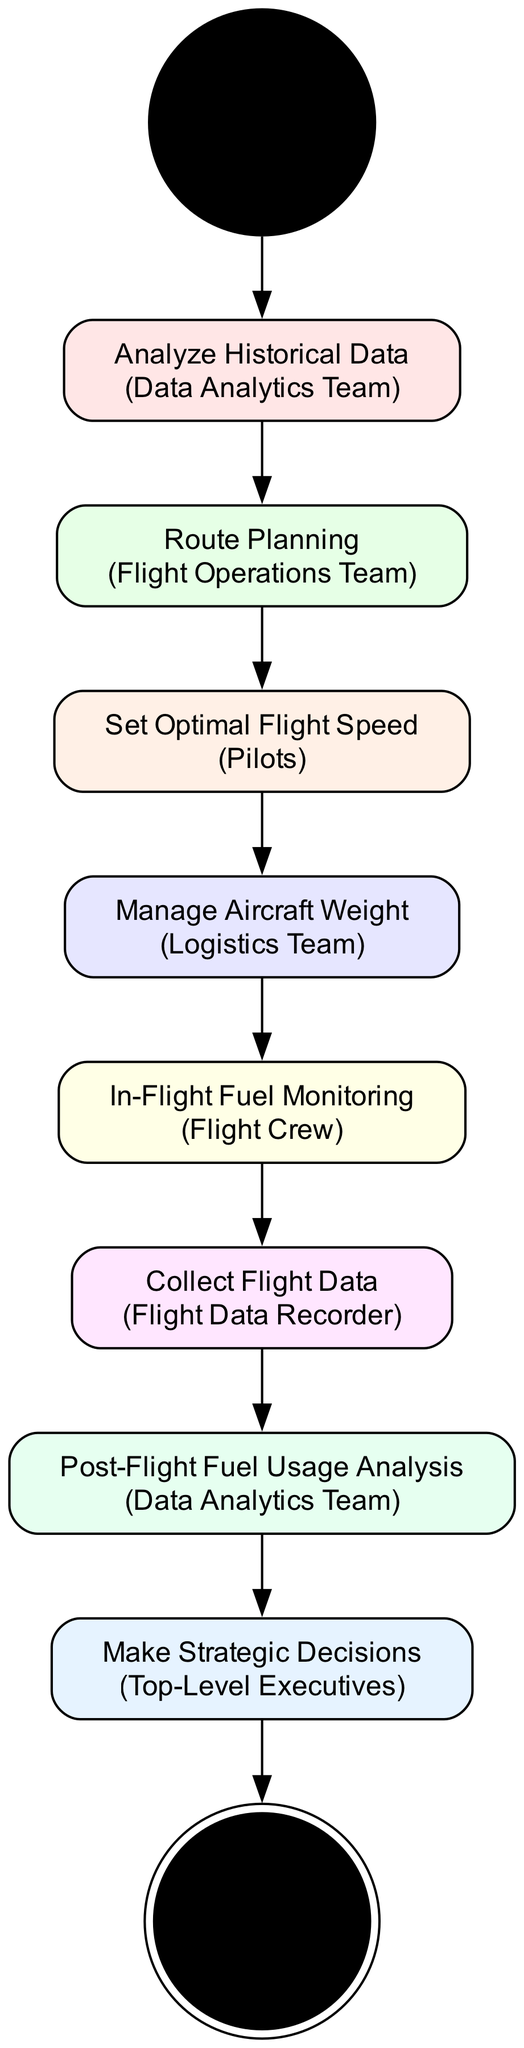What is the first activity in the diagram? The diagram starts with the "Start" node, which is the initial activity that indicates the beginning of the process.
Answer: Start How many total activities are represented in the diagram? The diagram includes a total of 9 activities from the "Start" to the "End," making it 9 distinct activities in total.
Answer: 9 Which team is responsible for "Route Planning"? The "Route Planning" activity is assigned to the "Flight Operations Team," as indicated in the description of that specific activity.
Answer: Flight Operations Team What is the last activity before reaching the "End"? The last activity that precedes the "End" node is "Make Strategic Decisions," which links the analysis results to the conclusion of the process.
Answer: Make Strategic Decisions Which activity follows "In-Flight Fuel Monitoring"? The "In-Flight Fuel Monitoring" activity is followed by the "Collect Flight Data" activity, which records fuel consumption details after monitoring.
Answer: Collect Flight Data What is the primary entity responsible for "Post-Flight Fuel Usage Analysis"? The "Post-Flight Fuel Usage Analysis" activity is handled by the "Data Analytics Team," as specified in its description.
Answer: Data Analytics Team Which activities are sequentially connected to "Manage Aircraft Weight"? The activity "Manage Aircraft Weight" is connected sequentially to "Set Optimal Flight Speed" followed by "In-Flight Fuel Monitoring."
Answer: Set Optimal Flight Speed, In-Flight Fuel Monitoring How many flows are present in the diagram? There are a total of 8 flows connecting the activities from the "Start" to the "End" node in the diagram.
Answer: 8 What type of node is "End"? The "End" node is identified as a "final_node," which indicates the conclusion of the activity flow in the diagram.
Answer: final_node 